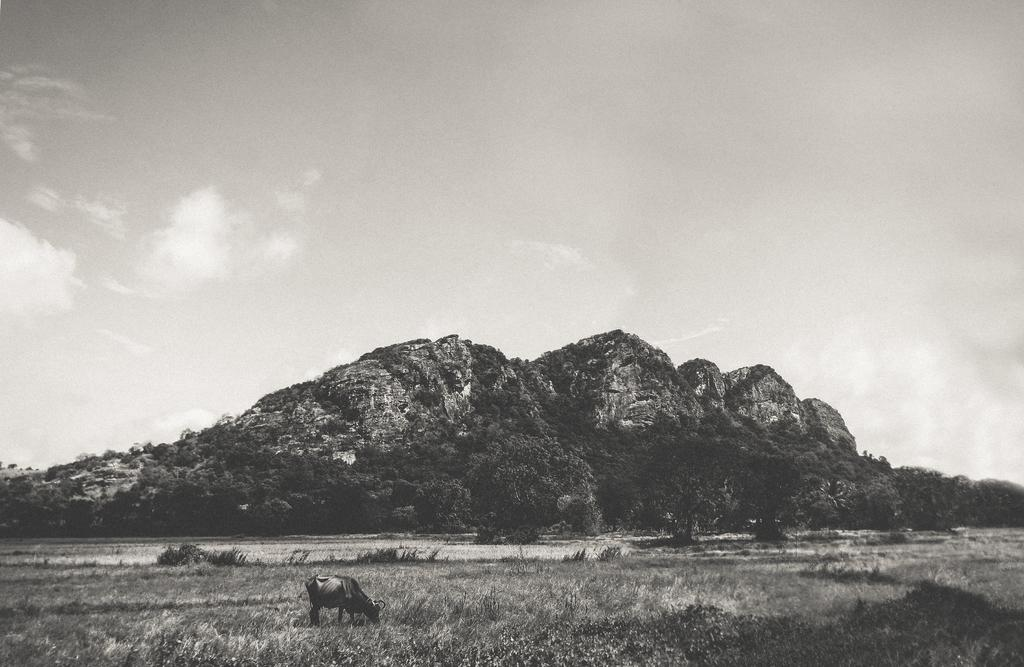What type of vegetation can be seen in the image? There are trees in the image. What geographical feature is present in the image? There is a hill in the image. What is covering the ground in the image? There is grass on the ground in the image. What animal is present in the image? A cow is grazing grass in the image. What is the condition of the sky in the image? The sky is cloudy in the image. Can you tell me how many credit is being managed in the image? There is no mention of credit or financial management in the image; it features a cow grazing on grass in a natural setting. Is there a scarf being used by the cow in the image? No, there is no scarf present in the image. 